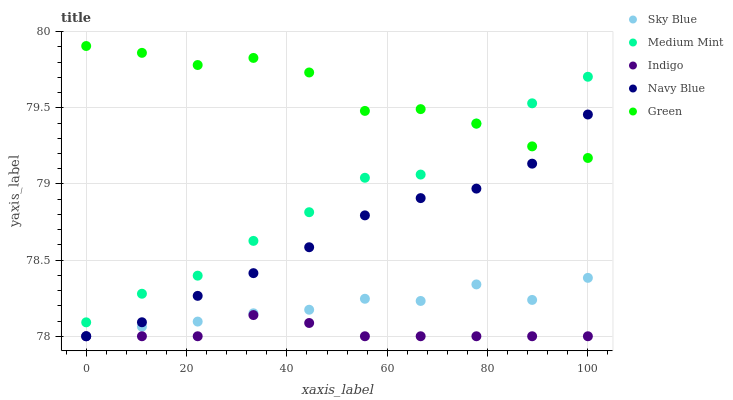Does Indigo have the minimum area under the curve?
Answer yes or no. Yes. Does Green have the maximum area under the curve?
Answer yes or no. Yes. Does Sky Blue have the minimum area under the curve?
Answer yes or no. No. Does Sky Blue have the maximum area under the curve?
Answer yes or no. No. Is Indigo the smoothest?
Answer yes or no. Yes. Is Medium Mint the roughest?
Answer yes or no. Yes. Is Sky Blue the smoothest?
Answer yes or no. No. Is Sky Blue the roughest?
Answer yes or no. No. Does Sky Blue have the lowest value?
Answer yes or no. Yes. Does Green have the lowest value?
Answer yes or no. No. Does Green have the highest value?
Answer yes or no. Yes. Does Sky Blue have the highest value?
Answer yes or no. No. Is Sky Blue less than Medium Mint?
Answer yes or no. Yes. Is Medium Mint greater than Navy Blue?
Answer yes or no. Yes. Does Green intersect Medium Mint?
Answer yes or no. Yes. Is Green less than Medium Mint?
Answer yes or no. No. Is Green greater than Medium Mint?
Answer yes or no. No. Does Sky Blue intersect Medium Mint?
Answer yes or no. No. 